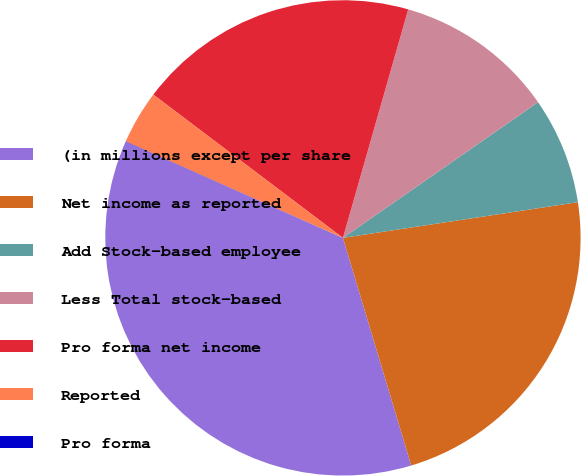Convert chart. <chart><loc_0><loc_0><loc_500><loc_500><pie_chart><fcel>(in millions except per share<fcel>Net income as reported<fcel>Add Stock-based employee<fcel>Less Total stock-based<fcel>Pro forma net income<fcel>Reported<fcel>Pro forma<nl><fcel>36.27%<fcel>22.76%<fcel>7.27%<fcel>10.9%<fcel>19.13%<fcel>3.65%<fcel>0.02%<nl></chart> 